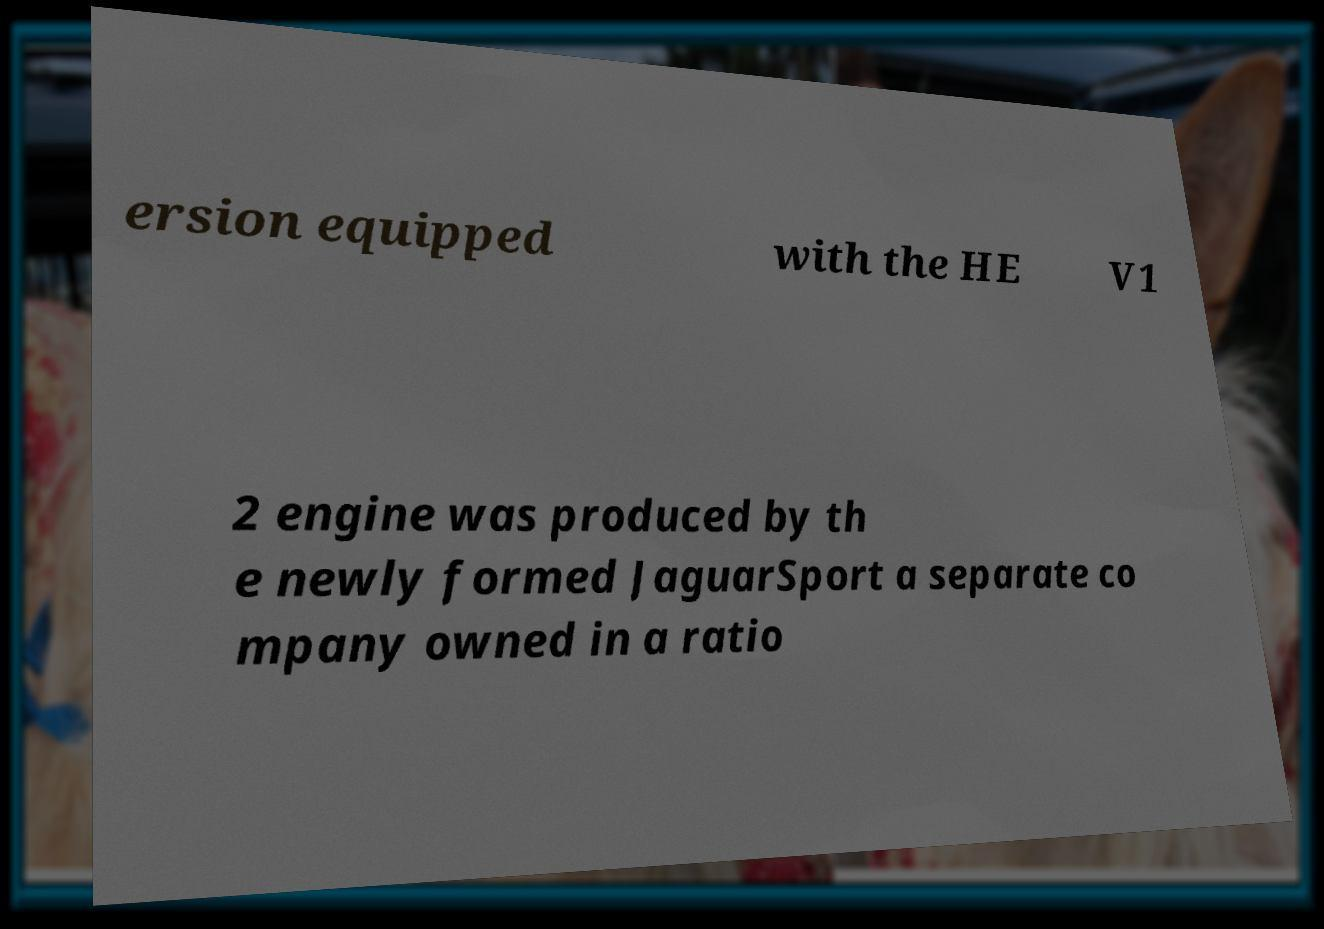I need the written content from this picture converted into text. Can you do that? ersion equipped with the HE V1 2 engine was produced by th e newly formed JaguarSport a separate co mpany owned in a ratio 